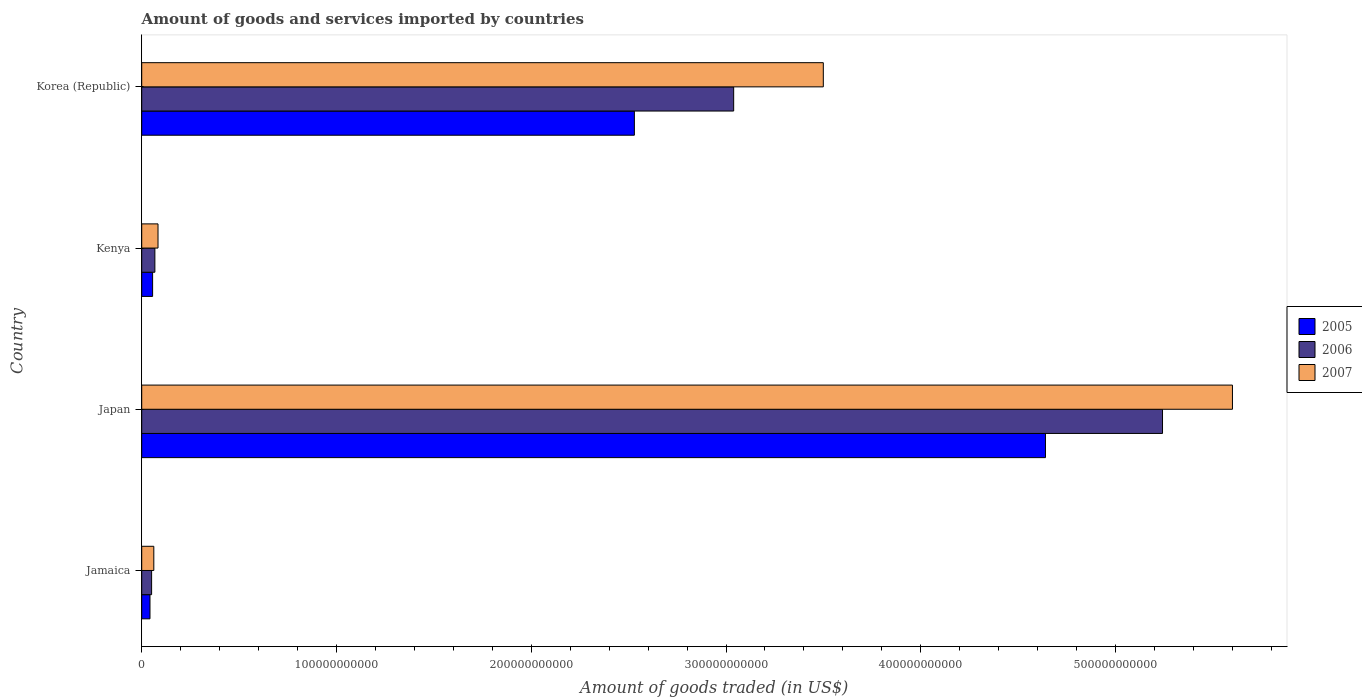How many groups of bars are there?
Your response must be concise. 4. How many bars are there on the 4th tick from the top?
Offer a terse response. 3. How many bars are there on the 4th tick from the bottom?
Your answer should be compact. 3. What is the total amount of goods and services imported in 2006 in Korea (Republic)?
Give a very brief answer. 3.04e+11. Across all countries, what is the maximum total amount of goods and services imported in 2005?
Ensure brevity in your answer.  4.64e+11. Across all countries, what is the minimum total amount of goods and services imported in 2006?
Provide a succinct answer. 5.08e+09. In which country was the total amount of goods and services imported in 2007 maximum?
Keep it short and to the point. Japan. In which country was the total amount of goods and services imported in 2006 minimum?
Your answer should be compact. Jamaica. What is the total total amount of goods and services imported in 2006 in the graph?
Your answer should be very brief. 8.40e+11. What is the difference between the total amount of goods and services imported in 2007 in Japan and that in Kenya?
Your answer should be compact. 5.52e+11. What is the difference between the total amount of goods and services imported in 2007 in Kenya and the total amount of goods and services imported in 2005 in Korea (Republic)?
Your answer should be compact. -2.45e+11. What is the average total amount of goods and services imported in 2007 per country?
Your response must be concise. 2.31e+11. What is the difference between the total amount of goods and services imported in 2007 and total amount of goods and services imported in 2005 in Korea (Republic)?
Provide a short and direct response. 9.70e+1. In how many countries, is the total amount of goods and services imported in 2006 greater than 80000000000 US$?
Provide a succinct answer. 2. What is the ratio of the total amount of goods and services imported in 2007 in Jamaica to that in Korea (Republic)?
Provide a short and direct response. 0.02. Is the total amount of goods and services imported in 2005 in Jamaica less than that in Kenya?
Ensure brevity in your answer.  Yes. What is the difference between the highest and the second highest total amount of goods and services imported in 2007?
Provide a short and direct response. 2.10e+11. What is the difference between the highest and the lowest total amount of goods and services imported in 2006?
Ensure brevity in your answer.  5.19e+11. Is the sum of the total amount of goods and services imported in 2006 in Japan and Korea (Republic) greater than the maximum total amount of goods and services imported in 2007 across all countries?
Your response must be concise. Yes. What is the difference between two consecutive major ticks on the X-axis?
Offer a terse response. 1.00e+11. Does the graph contain any zero values?
Give a very brief answer. No. Does the graph contain grids?
Offer a terse response. No. Where does the legend appear in the graph?
Your answer should be very brief. Center right. How many legend labels are there?
Offer a terse response. 3. What is the title of the graph?
Give a very brief answer. Amount of goods and services imported by countries. What is the label or title of the X-axis?
Your response must be concise. Amount of goods traded (in US$). What is the label or title of the Y-axis?
Ensure brevity in your answer.  Country. What is the Amount of goods traded (in US$) of 2005 in Jamaica?
Give a very brief answer. 4.25e+09. What is the Amount of goods traded (in US$) of 2006 in Jamaica?
Offer a very short reply. 5.08e+09. What is the Amount of goods traded (in US$) of 2007 in Jamaica?
Make the answer very short. 6.20e+09. What is the Amount of goods traded (in US$) of 2005 in Japan?
Your answer should be compact. 4.64e+11. What is the Amount of goods traded (in US$) in 2006 in Japan?
Provide a succinct answer. 5.24e+11. What is the Amount of goods traded (in US$) in 2007 in Japan?
Provide a succinct answer. 5.60e+11. What is the Amount of goods traded (in US$) in 2005 in Kenya?
Offer a terse response. 5.59e+09. What is the Amount of goods traded (in US$) of 2006 in Kenya?
Keep it short and to the point. 6.75e+09. What is the Amount of goods traded (in US$) in 2007 in Kenya?
Provide a succinct answer. 8.37e+09. What is the Amount of goods traded (in US$) of 2005 in Korea (Republic)?
Make the answer very short. 2.53e+11. What is the Amount of goods traded (in US$) of 2006 in Korea (Republic)?
Offer a terse response. 3.04e+11. What is the Amount of goods traded (in US$) of 2007 in Korea (Republic)?
Your answer should be compact. 3.50e+11. Across all countries, what is the maximum Amount of goods traded (in US$) in 2005?
Keep it short and to the point. 4.64e+11. Across all countries, what is the maximum Amount of goods traded (in US$) of 2006?
Offer a terse response. 5.24e+11. Across all countries, what is the maximum Amount of goods traded (in US$) of 2007?
Provide a succinct answer. 5.60e+11. Across all countries, what is the minimum Amount of goods traded (in US$) in 2005?
Keep it short and to the point. 4.25e+09. Across all countries, what is the minimum Amount of goods traded (in US$) in 2006?
Your response must be concise. 5.08e+09. Across all countries, what is the minimum Amount of goods traded (in US$) of 2007?
Your answer should be very brief. 6.20e+09. What is the total Amount of goods traded (in US$) in 2005 in the graph?
Keep it short and to the point. 7.27e+11. What is the total Amount of goods traded (in US$) of 2006 in the graph?
Offer a terse response. 8.40e+11. What is the total Amount of goods traded (in US$) of 2007 in the graph?
Offer a terse response. 9.25e+11. What is the difference between the Amount of goods traded (in US$) of 2005 in Jamaica and that in Japan?
Keep it short and to the point. -4.60e+11. What is the difference between the Amount of goods traded (in US$) of 2006 in Jamaica and that in Japan?
Offer a terse response. -5.19e+11. What is the difference between the Amount of goods traded (in US$) of 2007 in Jamaica and that in Japan?
Keep it short and to the point. -5.54e+11. What is the difference between the Amount of goods traded (in US$) in 2005 in Jamaica and that in Kenya?
Your answer should be very brief. -1.34e+09. What is the difference between the Amount of goods traded (in US$) in 2006 in Jamaica and that in Kenya?
Provide a short and direct response. -1.68e+09. What is the difference between the Amount of goods traded (in US$) of 2007 in Jamaica and that in Kenya?
Make the answer very short. -2.16e+09. What is the difference between the Amount of goods traded (in US$) in 2005 in Jamaica and that in Korea (Republic)?
Provide a succinct answer. -2.49e+11. What is the difference between the Amount of goods traded (in US$) of 2006 in Jamaica and that in Korea (Republic)?
Keep it short and to the point. -2.99e+11. What is the difference between the Amount of goods traded (in US$) in 2007 in Jamaica and that in Korea (Republic)?
Provide a succinct answer. -3.44e+11. What is the difference between the Amount of goods traded (in US$) in 2005 in Japan and that in Kenya?
Provide a succinct answer. 4.58e+11. What is the difference between the Amount of goods traded (in US$) in 2006 in Japan and that in Kenya?
Your answer should be very brief. 5.17e+11. What is the difference between the Amount of goods traded (in US$) in 2007 in Japan and that in Kenya?
Provide a short and direct response. 5.52e+11. What is the difference between the Amount of goods traded (in US$) of 2005 in Japan and that in Korea (Republic)?
Provide a succinct answer. 2.11e+11. What is the difference between the Amount of goods traded (in US$) of 2006 in Japan and that in Korea (Republic)?
Ensure brevity in your answer.  2.20e+11. What is the difference between the Amount of goods traded (in US$) in 2007 in Japan and that in Korea (Republic)?
Provide a short and direct response. 2.10e+11. What is the difference between the Amount of goods traded (in US$) of 2005 in Kenya and that in Korea (Republic)?
Your answer should be very brief. -2.47e+11. What is the difference between the Amount of goods traded (in US$) in 2006 in Kenya and that in Korea (Republic)?
Make the answer very short. -2.97e+11. What is the difference between the Amount of goods traded (in US$) of 2007 in Kenya and that in Korea (Republic)?
Your answer should be very brief. -3.42e+11. What is the difference between the Amount of goods traded (in US$) in 2005 in Jamaica and the Amount of goods traded (in US$) in 2006 in Japan?
Provide a short and direct response. -5.20e+11. What is the difference between the Amount of goods traded (in US$) of 2005 in Jamaica and the Amount of goods traded (in US$) of 2007 in Japan?
Make the answer very short. -5.56e+11. What is the difference between the Amount of goods traded (in US$) of 2006 in Jamaica and the Amount of goods traded (in US$) of 2007 in Japan?
Keep it short and to the point. -5.55e+11. What is the difference between the Amount of goods traded (in US$) of 2005 in Jamaica and the Amount of goods traded (in US$) of 2006 in Kenya?
Ensure brevity in your answer.  -2.51e+09. What is the difference between the Amount of goods traded (in US$) in 2005 in Jamaica and the Amount of goods traded (in US$) in 2007 in Kenya?
Make the answer very short. -4.12e+09. What is the difference between the Amount of goods traded (in US$) of 2006 in Jamaica and the Amount of goods traded (in US$) of 2007 in Kenya?
Offer a very short reply. -3.29e+09. What is the difference between the Amount of goods traded (in US$) of 2005 in Jamaica and the Amount of goods traded (in US$) of 2006 in Korea (Republic)?
Your answer should be compact. -3.00e+11. What is the difference between the Amount of goods traded (in US$) of 2005 in Jamaica and the Amount of goods traded (in US$) of 2007 in Korea (Republic)?
Provide a succinct answer. -3.46e+11. What is the difference between the Amount of goods traded (in US$) of 2006 in Jamaica and the Amount of goods traded (in US$) of 2007 in Korea (Republic)?
Ensure brevity in your answer.  -3.45e+11. What is the difference between the Amount of goods traded (in US$) of 2005 in Japan and the Amount of goods traded (in US$) of 2006 in Kenya?
Provide a succinct answer. 4.57e+11. What is the difference between the Amount of goods traded (in US$) of 2005 in Japan and the Amount of goods traded (in US$) of 2007 in Kenya?
Keep it short and to the point. 4.56e+11. What is the difference between the Amount of goods traded (in US$) in 2006 in Japan and the Amount of goods traded (in US$) in 2007 in Kenya?
Give a very brief answer. 5.16e+11. What is the difference between the Amount of goods traded (in US$) of 2005 in Japan and the Amount of goods traded (in US$) of 2006 in Korea (Republic)?
Offer a very short reply. 1.60e+11. What is the difference between the Amount of goods traded (in US$) of 2005 in Japan and the Amount of goods traded (in US$) of 2007 in Korea (Republic)?
Make the answer very short. 1.14e+11. What is the difference between the Amount of goods traded (in US$) in 2006 in Japan and the Amount of goods traded (in US$) in 2007 in Korea (Republic)?
Make the answer very short. 1.74e+11. What is the difference between the Amount of goods traded (in US$) of 2005 in Kenya and the Amount of goods traded (in US$) of 2006 in Korea (Republic)?
Your answer should be very brief. -2.98e+11. What is the difference between the Amount of goods traded (in US$) of 2005 in Kenya and the Amount of goods traded (in US$) of 2007 in Korea (Republic)?
Give a very brief answer. -3.44e+11. What is the difference between the Amount of goods traded (in US$) of 2006 in Kenya and the Amount of goods traded (in US$) of 2007 in Korea (Republic)?
Make the answer very short. -3.43e+11. What is the average Amount of goods traded (in US$) in 2005 per country?
Your answer should be very brief. 1.82e+11. What is the average Amount of goods traded (in US$) in 2006 per country?
Ensure brevity in your answer.  2.10e+11. What is the average Amount of goods traded (in US$) in 2007 per country?
Provide a succinct answer. 2.31e+11. What is the difference between the Amount of goods traded (in US$) of 2005 and Amount of goods traded (in US$) of 2006 in Jamaica?
Your response must be concise. -8.32e+08. What is the difference between the Amount of goods traded (in US$) in 2005 and Amount of goods traded (in US$) in 2007 in Jamaica?
Give a very brief answer. -1.96e+09. What is the difference between the Amount of goods traded (in US$) in 2006 and Amount of goods traded (in US$) in 2007 in Jamaica?
Offer a terse response. -1.13e+09. What is the difference between the Amount of goods traded (in US$) in 2005 and Amount of goods traded (in US$) in 2006 in Japan?
Ensure brevity in your answer.  -6.01e+1. What is the difference between the Amount of goods traded (in US$) of 2005 and Amount of goods traded (in US$) of 2007 in Japan?
Offer a very short reply. -9.60e+1. What is the difference between the Amount of goods traded (in US$) in 2006 and Amount of goods traded (in US$) in 2007 in Japan?
Offer a terse response. -3.59e+1. What is the difference between the Amount of goods traded (in US$) of 2005 and Amount of goods traded (in US$) of 2006 in Kenya?
Offer a terse response. -1.17e+09. What is the difference between the Amount of goods traded (in US$) in 2005 and Amount of goods traded (in US$) in 2007 in Kenya?
Make the answer very short. -2.78e+09. What is the difference between the Amount of goods traded (in US$) in 2006 and Amount of goods traded (in US$) in 2007 in Kenya?
Offer a very short reply. -1.62e+09. What is the difference between the Amount of goods traded (in US$) in 2005 and Amount of goods traded (in US$) in 2006 in Korea (Republic)?
Your response must be concise. -5.10e+1. What is the difference between the Amount of goods traded (in US$) in 2005 and Amount of goods traded (in US$) in 2007 in Korea (Republic)?
Your answer should be very brief. -9.70e+1. What is the difference between the Amount of goods traded (in US$) of 2006 and Amount of goods traded (in US$) of 2007 in Korea (Republic)?
Your answer should be very brief. -4.60e+1. What is the ratio of the Amount of goods traded (in US$) of 2005 in Jamaica to that in Japan?
Ensure brevity in your answer.  0.01. What is the ratio of the Amount of goods traded (in US$) of 2006 in Jamaica to that in Japan?
Ensure brevity in your answer.  0.01. What is the ratio of the Amount of goods traded (in US$) in 2007 in Jamaica to that in Japan?
Make the answer very short. 0.01. What is the ratio of the Amount of goods traded (in US$) in 2005 in Jamaica to that in Kenya?
Your answer should be very brief. 0.76. What is the ratio of the Amount of goods traded (in US$) of 2006 in Jamaica to that in Kenya?
Make the answer very short. 0.75. What is the ratio of the Amount of goods traded (in US$) of 2007 in Jamaica to that in Kenya?
Provide a succinct answer. 0.74. What is the ratio of the Amount of goods traded (in US$) in 2005 in Jamaica to that in Korea (Republic)?
Make the answer very short. 0.02. What is the ratio of the Amount of goods traded (in US$) of 2006 in Jamaica to that in Korea (Republic)?
Give a very brief answer. 0.02. What is the ratio of the Amount of goods traded (in US$) in 2007 in Jamaica to that in Korea (Republic)?
Keep it short and to the point. 0.02. What is the ratio of the Amount of goods traded (in US$) in 2005 in Japan to that in Kenya?
Keep it short and to the point. 83.06. What is the ratio of the Amount of goods traded (in US$) of 2006 in Japan to that in Kenya?
Provide a short and direct response. 77.62. What is the ratio of the Amount of goods traded (in US$) of 2007 in Japan to that in Kenya?
Provide a succinct answer. 66.92. What is the ratio of the Amount of goods traded (in US$) of 2005 in Japan to that in Korea (Republic)?
Provide a short and direct response. 1.83. What is the ratio of the Amount of goods traded (in US$) in 2006 in Japan to that in Korea (Republic)?
Give a very brief answer. 1.72. What is the ratio of the Amount of goods traded (in US$) of 2007 in Japan to that in Korea (Republic)?
Offer a very short reply. 1.6. What is the ratio of the Amount of goods traded (in US$) in 2005 in Kenya to that in Korea (Republic)?
Offer a very short reply. 0.02. What is the ratio of the Amount of goods traded (in US$) of 2006 in Kenya to that in Korea (Republic)?
Your answer should be compact. 0.02. What is the ratio of the Amount of goods traded (in US$) in 2007 in Kenya to that in Korea (Republic)?
Keep it short and to the point. 0.02. What is the difference between the highest and the second highest Amount of goods traded (in US$) of 2005?
Your response must be concise. 2.11e+11. What is the difference between the highest and the second highest Amount of goods traded (in US$) of 2006?
Provide a succinct answer. 2.20e+11. What is the difference between the highest and the second highest Amount of goods traded (in US$) in 2007?
Provide a short and direct response. 2.10e+11. What is the difference between the highest and the lowest Amount of goods traded (in US$) in 2005?
Make the answer very short. 4.60e+11. What is the difference between the highest and the lowest Amount of goods traded (in US$) in 2006?
Provide a succinct answer. 5.19e+11. What is the difference between the highest and the lowest Amount of goods traded (in US$) in 2007?
Ensure brevity in your answer.  5.54e+11. 